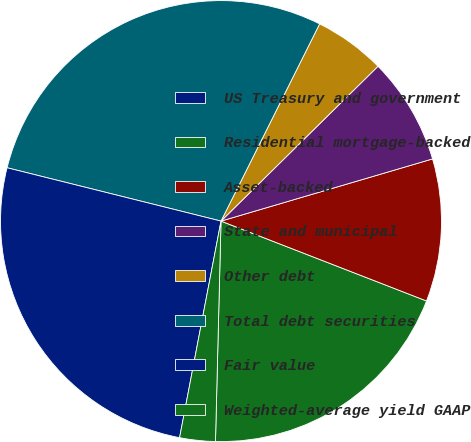<chart> <loc_0><loc_0><loc_500><loc_500><pie_chart><fcel>US Treasury and government<fcel>Residential mortgage-backed<fcel>Asset-backed<fcel>State and municipal<fcel>Other debt<fcel>Total debt securities<fcel>Fair value<fcel>Weighted-average yield GAAP<nl><fcel>0.0%<fcel>19.5%<fcel>10.45%<fcel>7.84%<fcel>5.23%<fcel>28.49%<fcel>25.88%<fcel>2.61%<nl></chart> 